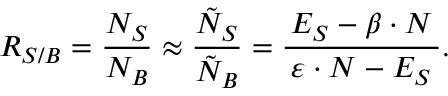<formula> <loc_0><loc_0><loc_500><loc_500>\, R _ { S / B } = \frac { N _ { S } } { N _ { B } } \approx \frac { \tilde { N } _ { S } } { \tilde { N } _ { B } } = \frac { \, E _ { S } - \beta \cdot N \, } { \varepsilon \cdot N - E _ { S } } .</formula> 